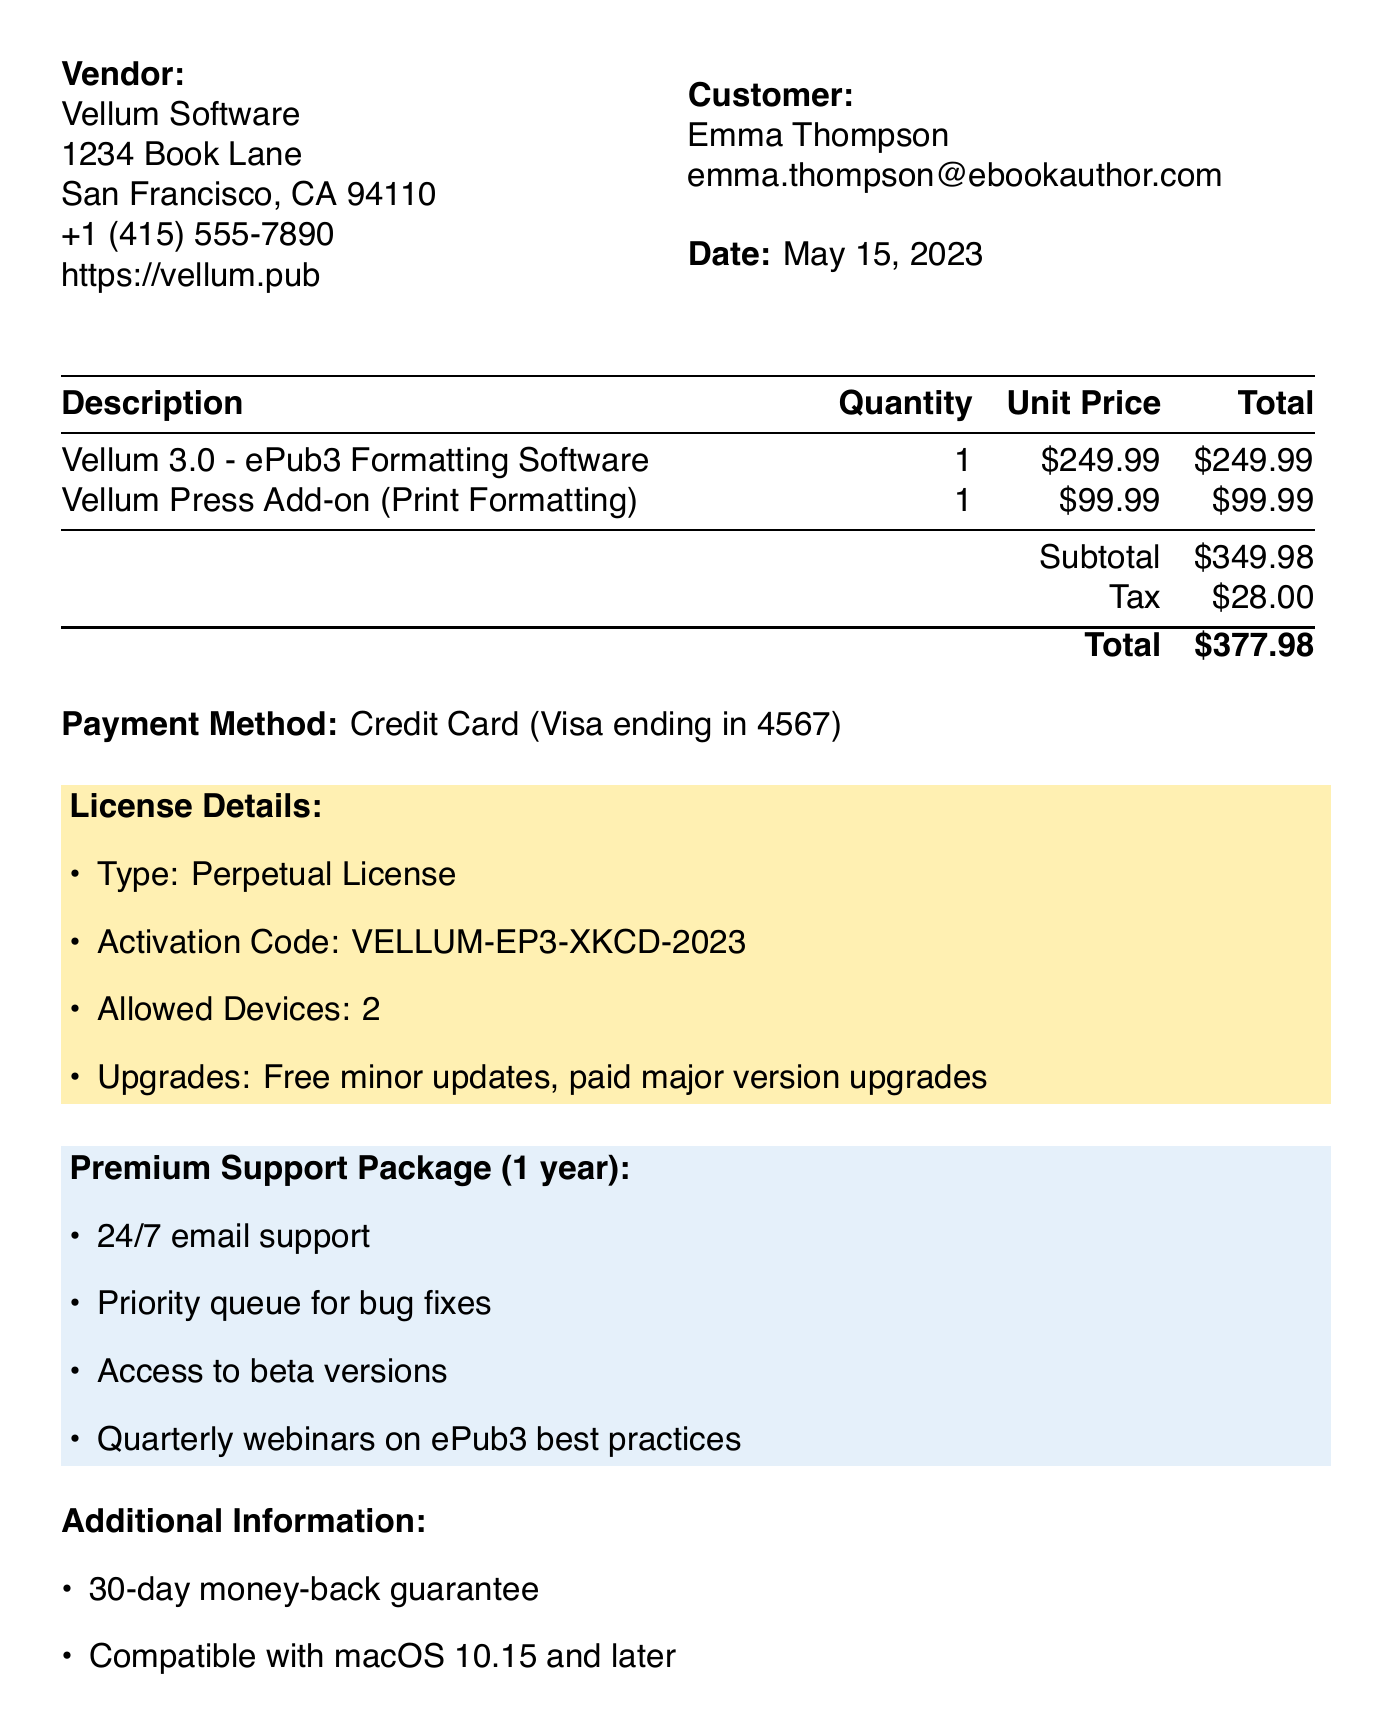What is the receipt number? The receipt number can be found at the top of the document and identifies this specific transaction.
Answer: INV-23875 Who is the vendor? The vendor's name is listed in the document, providing details of the seller of the software.
Answer: Vellum Software What is the total amount of the purchase? The total amount is calculated by adding the subtotal and tax, which is clearly indicated in the document.
Answer: $377.98 What type of license was purchased? The document specifies the license type associated with the software, indicating how the software can be used.
Answer: Perpetual License How long is the support package valid for? The duration of the support package is mentioned, detailing the period for which support is available.
Answer: 1 year What features are included in the Premium Support Package? The document lists several features under the support package, highlighting the benefits provided.
Answer: 24/7 email support, Priority queue for bug fixes, Access to beta versions, Quarterly webinars on ePub3 best practices What is the activation code provided? The activation code is found in the license details section and is necessary for activating the software.
Answer: VELLUM-EP3-XKCD-2023 What is the tax amount charged? The tax amount is specifically mentioned in the document, contributing to the total cost.
Answer: $28.00 What is the payment method used for this transaction? The document notes the payment method used, which can be found in the payment details section.
Answer: Credit Card (Visa ending in 4567) 